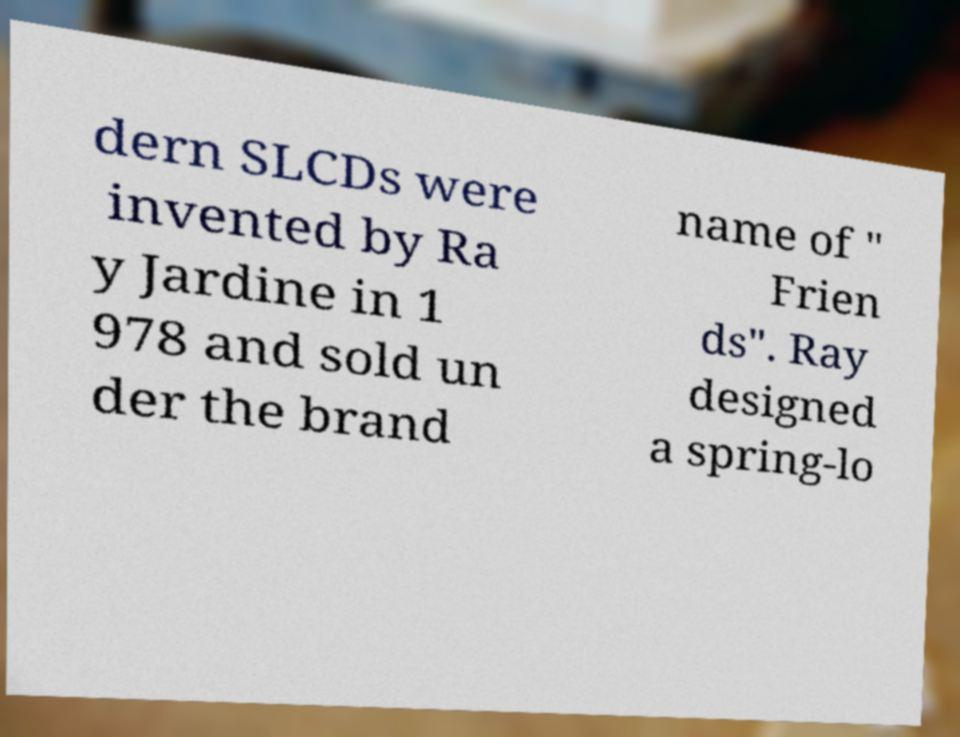Please identify and transcribe the text found in this image. dern SLCDs were invented by Ra y Jardine in 1 978 and sold un der the brand name of " Frien ds". Ray designed a spring-lo 